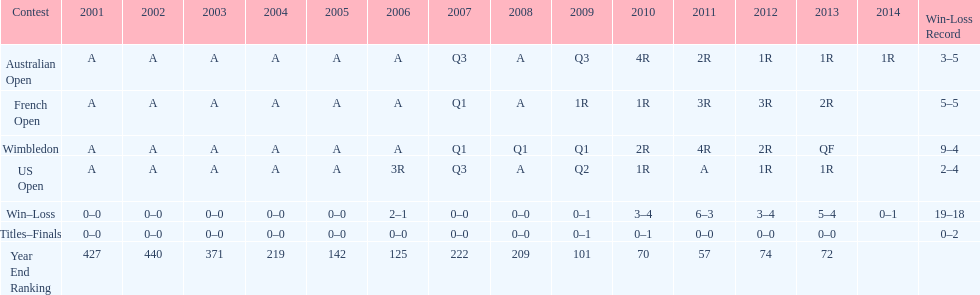How many tournaments had 5 total losses? 2. 